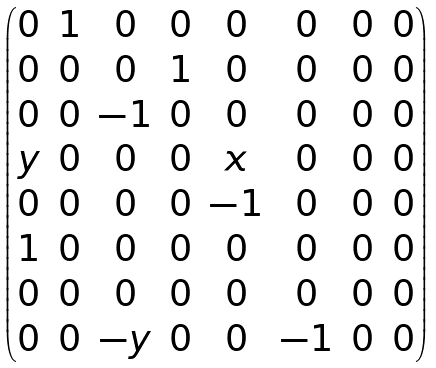<formula> <loc_0><loc_0><loc_500><loc_500>\begin{pmatrix} 0 & 1 & 0 & 0 & 0 & 0 & 0 & 0 \\ 0 & 0 & 0 & 1 & 0 & 0 & 0 & 0 \\ 0 & 0 & - 1 & 0 & 0 & 0 & 0 & 0 \\ y & 0 & 0 & 0 & x & 0 & 0 & 0 \\ 0 & 0 & 0 & 0 & - 1 & 0 & 0 & 0 \\ 1 & 0 & 0 & 0 & 0 & 0 & 0 & 0 \\ 0 & 0 & 0 & 0 & 0 & 0 & 0 & 0 \\ 0 & 0 & - y & 0 & 0 & - 1 & 0 & 0 \end{pmatrix}</formula> 